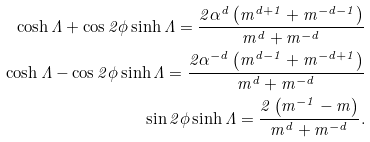<formula> <loc_0><loc_0><loc_500><loc_500>\cosh { \Lambda } + \cos 2 \phi \sinh { \Lambda } = \frac { 2 \alpha ^ { d } \left ( m ^ { d + 1 } + m ^ { - d - 1 } \right ) } { m ^ { d } + m ^ { - d } } \\ \cosh { \Lambda } - \cos 2 \phi \sinh { \Lambda } = \frac { 2 \alpha ^ { - d } \left ( m ^ { d - 1 } + m ^ { - d + 1 } \right ) } { m ^ { d } + m ^ { - d } } \\ \sin 2 \phi \sinh { \Lambda } = \frac { 2 \left ( m ^ { - 1 } - m \right ) } { m ^ { d } + m ^ { - d } } .</formula> 